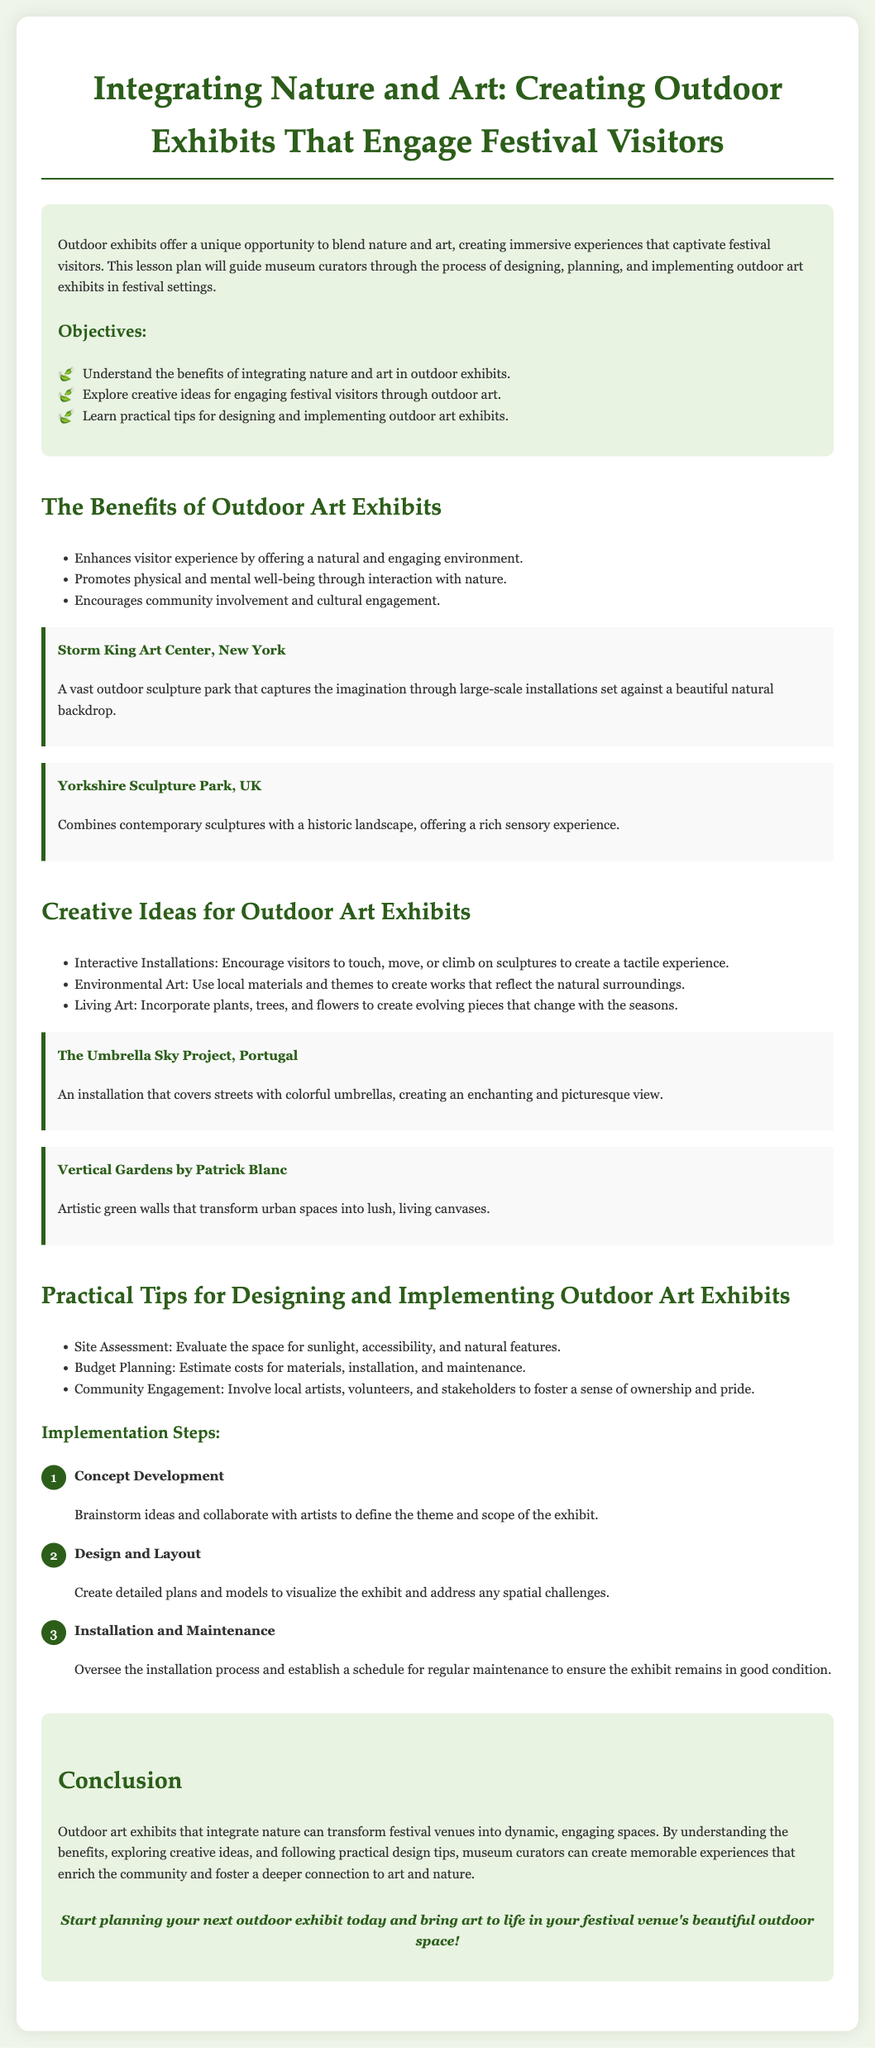what is the title of the lesson plan? The title appears prominently at the top of the document, introducing the subject matter.
Answer: Integrating Nature and Art: Creating Outdoor Exhibits That Engage Festival Visitors what are the three main objectives listed in the lesson plan? The objectives are specifically outlined under the Objectives section in a bullet-point list.
Answer: Understand the benefits of integrating nature and art in outdoor exhibits, Explore creative ideas for engaging festival visitors through outdoor art, Learn practical tips for designing and implementing outdoor art exhibits what is the first example of an outdoor art exhibit mentioned? The first example provided is located in the section discussing the benefits of outdoor art exhibits.
Answer: Storm King Art Center, New York how many implementation steps are outlined in the lesson plan? The number of steps can be counted in the Implementation Steps section.
Answer: 3 what type of art does The Umbrella Sky Project represent? The Umbrella Sky Project falls under a specific category of outdoor art described in the creative ideas section.
Answer: Installation what is a practical tip for designing outdoor exhibits? One of the practical tips can be found in the Designing and Implementing section, described in a bullet point.
Answer: Site Assessment which city's project combines contemporary sculptures with a historic landscape? This information is available in a specific example listed under the benefits section of the lesson plan.
Answer: Yorkshire what color is used for the background of the document? The background color is mentioned in the styling section and informs the visual presentation of the entire document.
Answer: #f0f5e9 